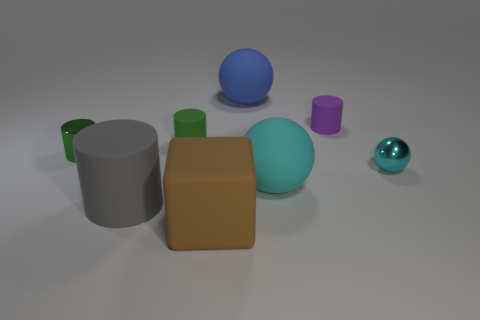Do the blue sphere and the tiny cyan ball have the same material?
Provide a short and direct response. No. There is a rubber cylinder that is both behind the cyan metal sphere and in front of the purple thing; what color is it?
Provide a succinct answer. Green. Is there a purple rubber cylinder that has the same size as the purple matte thing?
Give a very brief answer. No. There is a matte cylinder that is on the right side of the large matte thing behind the big cyan rubber ball; how big is it?
Your answer should be very brief. Small. Are there fewer gray cylinders to the right of the tiny green rubber thing than big brown metal objects?
Make the answer very short. No. What is the size of the green rubber cylinder?
Your answer should be compact. Small. How many small rubber cylinders are the same color as the metallic cylinder?
Make the answer very short. 1. Are there any gray objects in front of the ball that is on the right side of the matte cylinder to the right of the large blue matte object?
Give a very brief answer. Yes. The purple object that is the same size as the green metallic object is what shape?
Your answer should be compact. Cylinder. What number of small things are blue metallic things or metal things?
Offer a very short reply. 2. 